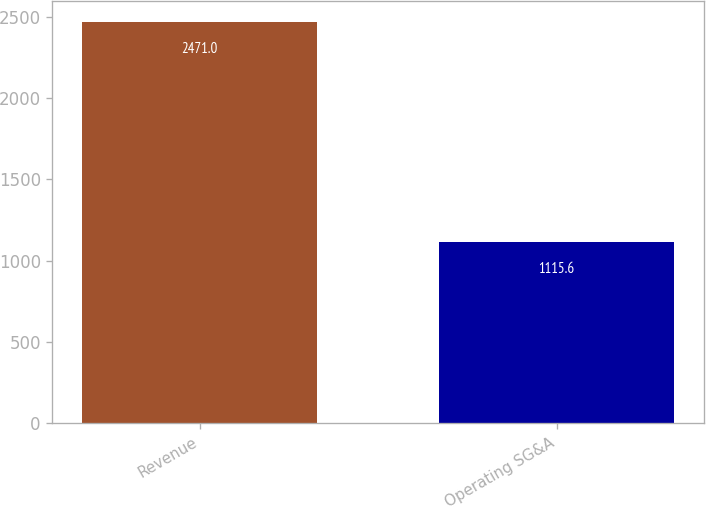Convert chart to OTSL. <chart><loc_0><loc_0><loc_500><loc_500><bar_chart><fcel>Revenue<fcel>Operating SG&A<nl><fcel>2471<fcel>1115.6<nl></chart> 